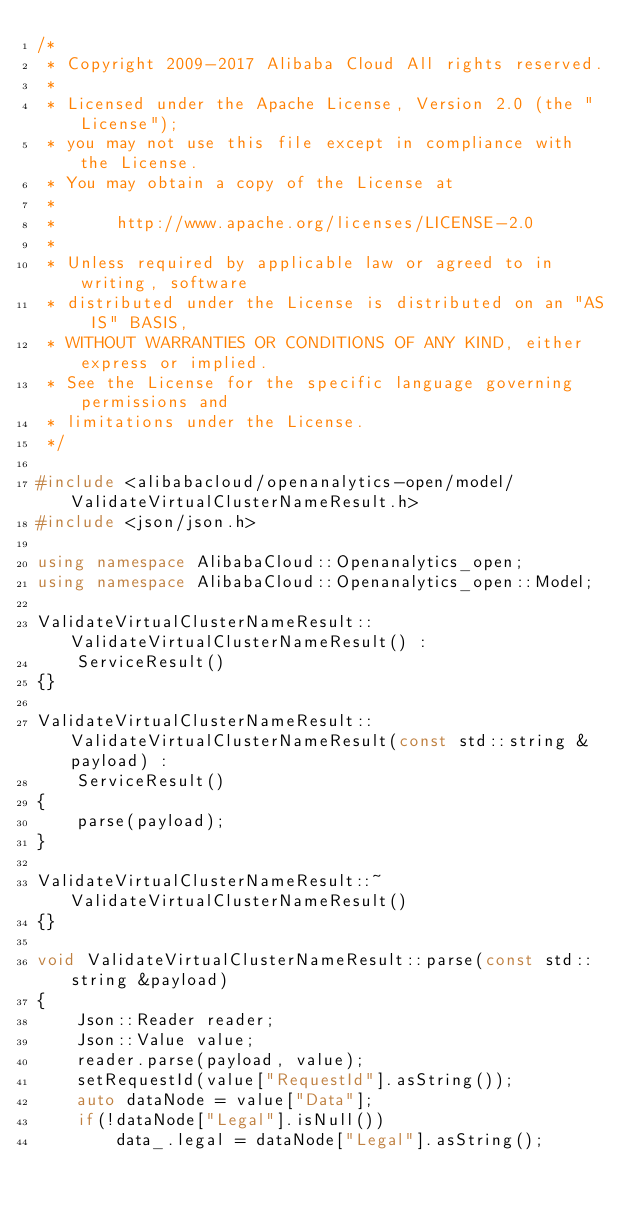Convert code to text. <code><loc_0><loc_0><loc_500><loc_500><_C++_>/*
 * Copyright 2009-2017 Alibaba Cloud All rights reserved.
 * 
 * Licensed under the Apache License, Version 2.0 (the "License");
 * you may not use this file except in compliance with the License.
 * You may obtain a copy of the License at
 * 
 *      http://www.apache.org/licenses/LICENSE-2.0
 * 
 * Unless required by applicable law or agreed to in writing, software
 * distributed under the License is distributed on an "AS IS" BASIS,
 * WITHOUT WARRANTIES OR CONDITIONS OF ANY KIND, either express or implied.
 * See the License for the specific language governing permissions and
 * limitations under the License.
 */

#include <alibabacloud/openanalytics-open/model/ValidateVirtualClusterNameResult.h>
#include <json/json.h>

using namespace AlibabaCloud::Openanalytics_open;
using namespace AlibabaCloud::Openanalytics_open::Model;

ValidateVirtualClusterNameResult::ValidateVirtualClusterNameResult() :
	ServiceResult()
{}

ValidateVirtualClusterNameResult::ValidateVirtualClusterNameResult(const std::string &payload) :
	ServiceResult()
{
	parse(payload);
}

ValidateVirtualClusterNameResult::~ValidateVirtualClusterNameResult()
{}

void ValidateVirtualClusterNameResult::parse(const std::string &payload)
{
	Json::Reader reader;
	Json::Value value;
	reader.parse(payload, value);
	setRequestId(value["RequestId"].asString());
	auto dataNode = value["Data"];
	if(!dataNode["Legal"].isNull())
		data_.legal = dataNode["Legal"].asString();</code> 